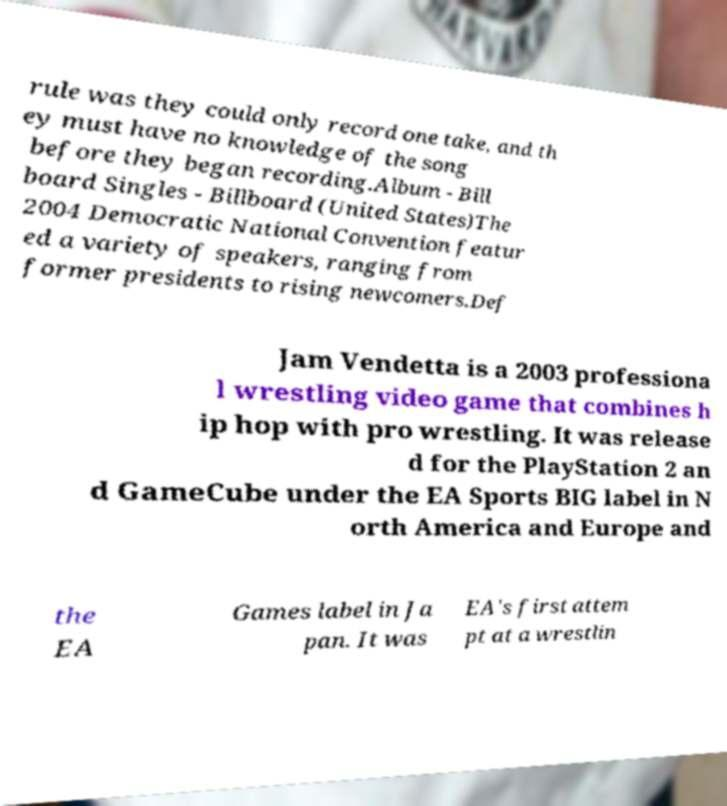Can you read and provide the text displayed in the image?This photo seems to have some interesting text. Can you extract and type it out for me? rule was they could only record one take, and th ey must have no knowledge of the song before they began recording.Album - Bill board Singles - Billboard (United States)The 2004 Democratic National Convention featur ed a variety of speakers, ranging from former presidents to rising newcomers.Def Jam Vendetta is a 2003 professiona l wrestling video game that combines h ip hop with pro wrestling. It was release d for the PlayStation 2 an d GameCube under the EA Sports BIG label in N orth America and Europe and the EA Games label in Ja pan. It was EA's first attem pt at a wrestlin 